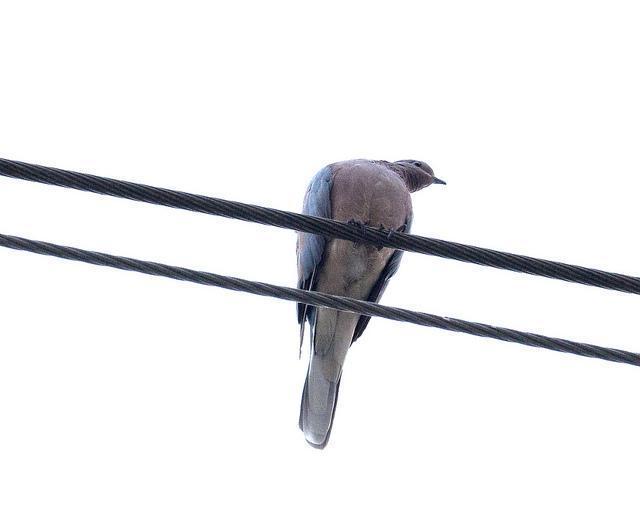How many train cars are there?
Give a very brief answer. 0. 